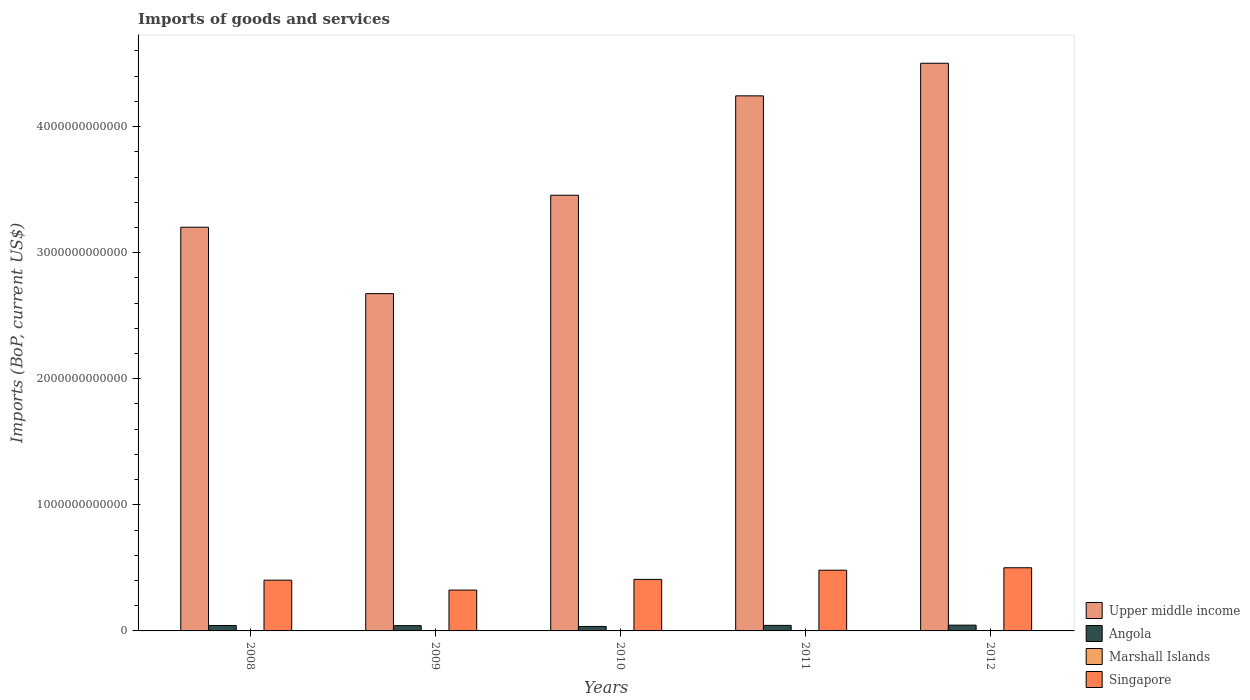How many different coloured bars are there?
Offer a terse response. 4. How many bars are there on the 5th tick from the left?
Provide a succinct answer. 4. What is the amount spent on imports in Angola in 2011?
Your answer should be compact. 4.39e+1. Across all years, what is the maximum amount spent on imports in Marshall Islands?
Your response must be concise. 1.82e+08. Across all years, what is the minimum amount spent on imports in Upper middle income?
Your answer should be compact. 2.68e+12. What is the total amount spent on imports in Angola in the graph?
Give a very brief answer. 2.10e+11. What is the difference between the amount spent on imports in Marshall Islands in 2008 and that in 2010?
Your answer should be very brief. -2.45e+07. What is the difference between the amount spent on imports in Singapore in 2008 and the amount spent on imports in Upper middle income in 2009?
Your response must be concise. -2.27e+12. What is the average amount spent on imports in Singapore per year?
Provide a succinct answer. 4.24e+11. In the year 2010, what is the difference between the amount spent on imports in Singapore and amount spent on imports in Marshall Islands?
Keep it short and to the point. 4.08e+11. In how many years, is the amount spent on imports in Marshall Islands greater than 200000000000 US$?
Your answer should be compact. 0. What is the ratio of the amount spent on imports in Marshall Islands in 2010 to that in 2012?
Your answer should be compact. 0.9. Is the amount spent on imports in Marshall Islands in 2008 less than that in 2012?
Offer a terse response. Yes. What is the difference between the highest and the second highest amount spent on imports in Angola?
Provide a succinct answer. 1.94e+09. What is the difference between the highest and the lowest amount spent on imports in Upper middle income?
Offer a terse response. 1.83e+12. In how many years, is the amount spent on imports in Angola greater than the average amount spent on imports in Angola taken over all years?
Provide a succinct answer. 3. Is the sum of the amount spent on imports in Marshall Islands in 2008 and 2009 greater than the maximum amount spent on imports in Angola across all years?
Keep it short and to the point. No. What does the 2nd bar from the left in 2012 represents?
Provide a short and direct response. Angola. What does the 1st bar from the right in 2011 represents?
Provide a short and direct response. Singapore. How many bars are there?
Your response must be concise. 20. How many years are there in the graph?
Offer a very short reply. 5. What is the difference between two consecutive major ticks on the Y-axis?
Give a very brief answer. 1.00e+12. Are the values on the major ticks of Y-axis written in scientific E-notation?
Ensure brevity in your answer.  No. Does the graph contain any zero values?
Keep it short and to the point. No. Does the graph contain grids?
Give a very brief answer. No. Where does the legend appear in the graph?
Keep it short and to the point. Bottom right. What is the title of the graph?
Provide a succinct answer. Imports of goods and services. Does "Dominica" appear as one of the legend labels in the graph?
Give a very brief answer. No. What is the label or title of the X-axis?
Keep it short and to the point. Years. What is the label or title of the Y-axis?
Offer a very short reply. Imports (BoP, current US$). What is the Imports (BoP, current US$) in Upper middle income in 2008?
Your answer should be very brief. 3.20e+12. What is the Imports (BoP, current US$) of Angola in 2008?
Keep it short and to the point. 4.31e+1. What is the Imports (BoP, current US$) of Marshall Islands in 2008?
Ensure brevity in your answer.  1.39e+08. What is the Imports (BoP, current US$) of Singapore in 2008?
Provide a succinct answer. 4.03e+11. What is the Imports (BoP, current US$) of Upper middle income in 2009?
Your response must be concise. 2.68e+12. What is the Imports (BoP, current US$) in Angola in 2009?
Make the answer very short. 4.18e+1. What is the Imports (BoP, current US$) of Marshall Islands in 2009?
Make the answer very short. 1.58e+08. What is the Imports (BoP, current US$) of Singapore in 2009?
Make the answer very short. 3.24e+11. What is the Imports (BoP, current US$) of Upper middle income in 2010?
Ensure brevity in your answer.  3.46e+12. What is the Imports (BoP, current US$) of Angola in 2010?
Give a very brief answer. 3.54e+1. What is the Imports (BoP, current US$) of Marshall Islands in 2010?
Offer a terse response. 1.64e+08. What is the Imports (BoP, current US$) in Singapore in 2010?
Offer a very short reply. 4.09e+11. What is the Imports (BoP, current US$) of Upper middle income in 2011?
Give a very brief answer. 4.24e+12. What is the Imports (BoP, current US$) of Angola in 2011?
Your answer should be very brief. 4.39e+1. What is the Imports (BoP, current US$) in Marshall Islands in 2011?
Ensure brevity in your answer.  1.75e+08. What is the Imports (BoP, current US$) of Singapore in 2011?
Offer a terse response. 4.82e+11. What is the Imports (BoP, current US$) in Upper middle income in 2012?
Your response must be concise. 4.50e+12. What is the Imports (BoP, current US$) in Angola in 2012?
Offer a very short reply. 4.58e+1. What is the Imports (BoP, current US$) of Marshall Islands in 2012?
Your answer should be very brief. 1.82e+08. What is the Imports (BoP, current US$) in Singapore in 2012?
Your response must be concise. 5.01e+11. Across all years, what is the maximum Imports (BoP, current US$) of Upper middle income?
Provide a succinct answer. 4.50e+12. Across all years, what is the maximum Imports (BoP, current US$) in Angola?
Ensure brevity in your answer.  4.58e+1. Across all years, what is the maximum Imports (BoP, current US$) in Marshall Islands?
Ensure brevity in your answer.  1.82e+08. Across all years, what is the maximum Imports (BoP, current US$) of Singapore?
Your response must be concise. 5.01e+11. Across all years, what is the minimum Imports (BoP, current US$) of Upper middle income?
Ensure brevity in your answer.  2.68e+12. Across all years, what is the minimum Imports (BoP, current US$) in Angola?
Your response must be concise. 3.54e+1. Across all years, what is the minimum Imports (BoP, current US$) in Marshall Islands?
Offer a very short reply. 1.39e+08. Across all years, what is the minimum Imports (BoP, current US$) in Singapore?
Ensure brevity in your answer.  3.24e+11. What is the total Imports (BoP, current US$) in Upper middle income in the graph?
Provide a short and direct response. 1.81e+13. What is the total Imports (BoP, current US$) in Angola in the graph?
Offer a terse response. 2.10e+11. What is the total Imports (BoP, current US$) of Marshall Islands in the graph?
Your response must be concise. 8.18e+08. What is the total Imports (BoP, current US$) of Singapore in the graph?
Offer a very short reply. 2.12e+12. What is the difference between the Imports (BoP, current US$) in Upper middle income in 2008 and that in 2009?
Ensure brevity in your answer.  5.27e+11. What is the difference between the Imports (BoP, current US$) of Angola in 2008 and that in 2009?
Ensure brevity in your answer.  1.29e+09. What is the difference between the Imports (BoP, current US$) of Marshall Islands in 2008 and that in 2009?
Provide a short and direct response. -1.88e+07. What is the difference between the Imports (BoP, current US$) of Singapore in 2008 and that in 2009?
Ensure brevity in your answer.  7.86e+1. What is the difference between the Imports (BoP, current US$) in Upper middle income in 2008 and that in 2010?
Your response must be concise. -2.54e+11. What is the difference between the Imports (BoP, current US$) of Angola in 2008 and that in 2010?
Keep it short and to the point. 7.70e+09. What is the difference between the Imports (BoP, current US$) of Marshall Islands in 2008 and that in 2010?
Your answer should be compact. -2.45e+07. What is the difference between the Imports (BoP, current US$) in Singapore in 2008 and that in 2010?
Your answer should be compact. -6.12e+09. What is the difference between the Imports (BoP, current US$) in Upper middle income in 2008 and that in 2011?
Make the answer very short. -1.04e+12. What is the difference between the Imports (BoP, current US$) in Angola in 2008 and that in 2011?
Provide a short and direct response. -7.77e+08. What is the difference between the Imports (BoP, current US$) in Marshall Islands in 2008 and that in 2011?
Your answer should be compact. -3.58e+07. What is the difference between the Imports (BoP, current US$) of Singapore in 2008 and that in 2011?
Give a very brief answer. -7.90e+1. What is the difference between the Imports (BoP, current US$) in Upper middle income in 2008 and that in 2012?
Your response must be concise. -1.30e+12. What is the difference between the Imports (BoP, current US$) of Angola in 2008 and that in 2012?
Offer a terse response. -2.71e+09. What is the difference between the Imports (BoP, current US$) of Marshall Islands in 2008 and that in 2012?
Your response must be concise. -4.28e+07. What is the difference between the Imports (BoP, current US$) of Singapore in 2008 and that in 2012?
Ensure brevity in your answer.  -9.85e+1. What is the difference between the Imports (BoP, current US$) in Upper middle income in 2009 and that in 2010?
Offer a very short reply. -7.80e+11. What is the difference between the Imports (BoP, current US$) in Angola in 2009 and that in 2010?
Provide a short and direct response. 6.41e+09. What is the difference between the Imports (BoP, current US$) of Marshall Islands in 2009 and that in 2010?
Ensure brevity in your answer.  -5.73e+06. What is the difference between the Imports (BoP, current US$) of Singapore in 2009 and that in 2010?
Your answer should be compact. -8.47e+1. What is the difference between the Imports (BoP, current US$) of Upper middle income in 2009 and that in 2011?
Keep it short and to the point. -1.57e+12. What is the difference between the Imports (BoP, current US$) in Angola in 2009 and that in 2011?
Ensure brevity in your answer.  -2.07e+09. What is the difference between the Imports (BoP, current US$) of Marshall Islands in 2009 and that in 2011?
Your answer should be very brief. -1.70e+07. What is the difference between the Imports (BoP, current US$) of Singapore in 2009 and that in 2011?
Your answer should be very brief. -1.58e+11. What is the difference between the Imports (BoP, current US$) of Upper middle income in 2009 and that in 2012?
Give a very brief answer. -1.83e+12. What is the difference between the Imports (BoP, current US$) of Angola in 2009 and that in 2012?
Make the answer very short. -4.01e+09. What is the difference between the Imports (BoP, current US$) of Marshall Islands in 2009 and that in 2012?
Give a very brief answer. -2.41e+07. What is the difference between the Imports (BoP, current US$) of Singapore in 2009 and that in 2012?
Offer a terse response. -1.77e+11. What is the difference between the Imports (BoP, current US$) in Upper middle income in 2010 and that in 2011?
Your response must be concise. -7.88e+11. What is the difference between the Imports (BoP, current US$) of Angola in 2010 and that in 2011?
Give a very brief answer. -8.48e+09. What is the difference between the Imports (BoP, current US$) of Marshall Islands in 2010 and that in 2011?
Offer a very short reply. -1.13e+07. What is the difference between the Imports (BoP, current US$) of Singapore in 2010 and that in 2011?
Offer a terse response. -7.29e+1. What is the difference between the Imports (BoP, current US$) of Upper middle income in 2010 and that in 2012?
Your answer should be compact. -1.05e+12. What is the difference between the Imports (BoP, current US$) in Angola in 2010 and that in 2012?
Your answer should be compact. -1.04e+1. What is the difference between the Imports (BoP, current US$) of Marshall Islands in 2010 and that in 2012?
Keep it short and to the point. -1.83e+07. What is the difference between the Imports (BoP, current US$) of Singapore in 2010 and that in 2012?
Offer a terse response. -9.24e+1. What is the difference between the Imports (BoP, current US$) of Upper middle income in 2011 and that in 2012?
Give a very brief answer. -2.58e+11. What is the difference between the Imports (BoP, current US$) of Angola in 2011 and that in 2012?
Provide a short and direct response. -1.94e+09. What is the difference between the Imports (BoP, current US$) in Marshall Islands in 2011 and that in 2012?
Your answer should be compact. -7.07e+06. What is the difference between the Imports (BoP, current US$) in Singapore in 2011 and that in 2012?
Give a very brief answer. -1.94e+1. What is the difference between the Imports (BoP, current US$) in Upper middle income in 2008 and the Imports (BoP, current US$) in Angola in 2009?
Your answer should be very brief. 3.16e+12. What is the difference between the Imports (BoP, current US$) in Upper middle income in 2008 and the Imports (BoP, current US$) in Marshall Islands in 2009?
Your answer should be very brief. 3.20e+12. What is the difference between the Imports (BoP, current US$) of Upper middle income in 2008 and the Imports (BoP, current US$) of Singapore in 2009?
Ensure brevity in your answer.  2.88e+12. What is the difference between the Imports (BoP, current US$) of Angola in 2008 and the Imports (BoP, current US$) of Marshall Islands in 2009?
Keep it short and to the point. 4.30e+1. What is the difference between the Imports (BoP, current US$) in Angola in 2008 and the Imports (BoP, current US$) in Singapore in 2009?
Offer a very short reply. -2.81e+11. What is the difference between the Imports (BoP, current US$) of Marshall Islands in 2008 and the Imports (BoP, current US$) of Singapore in 2009?
Offer a terse response. -3.24e+11. What is the difference between the Imports (BoP, current US$) in Upper middle income in 2008 and the Imports (BoP, current US$) in Angola in 2010?
Make the answer very short. 3.17e+12. What is the difference between the Imports (BoP, current US$) of Upper middle income in 2008 and the Imports (BoP, current US$) of Marshall Islands in 2010?
Provide a succinct answer. 3.20e+12. What is the difference between the Imports (BoP, current US$) in Upper middle income in 2008 and the Imports (BoP, current US$) in Singapore in 2010?
Offer a very short reply. 2.79e+12. What is the difference between the Imports (BoP, current US$) in Angola in 2008 and the Imports (BoP, current US$) in Marshall Islands in 2010?
Your answer should be compact. 4.30e+1. What is the difference between the Imports (BoP, current US$) in Angola in 2008 and the Imports (BoP, current US$) in Singapore in 2010?
Offer a very short reply. -3.66e+11. What is the difference between the Imports (BoP, current US$) of Marshall Islands in 2008 and the Imports (BoP, current US$) of Singapore in 2010?
Your answer should be very brief. -4.08e+11. What is the difference between the Imports (BoP, current US$) in Upper middle income in 2008 and the Imports (BoP, current US$) in Angola in 2011?
Your answer should be very brief. 3.16e+12. What is the difference between the Imports (BoP, current US$) in Upper middle income in 2008 and the Imports (BoP, current US$) in Marshall Islands in 2011?
Your answer should be very brief. 3.20e+12. What is the difference between the Imports (BoP, current US$) of Upper middle income in 2008 and the Imports (BoP, current US$) of Singapore in 2011?
Keep it short and to the point. 2.72e+12. What is the difference between the Imports (BoP, current US$) in Angola in 2008 and the Imports (BoP, current US$) in Marshall Islands in 2011?
Make the answer very short. 4.29e+1. What is the difference between the Imports (BoP, current US$) in Angola in 2008 and the Imports (BoP, current US$) in Singapore in 2011?
Offer a very short reply. -4.38e+11. What is the difference between the Imports (BoP, current US$) of Marshall Islands in 2008 and the Imports (BoP, current US$) of Singapore in 2011?
Your answer should be compact. -4.81e+11. What is the difference between the Imports (BoP, current US$) of Upper middle income in 2008 and the Imports (BoP, current US$) of Angola in 2012?
Provide a succinct answer. 3.16e+12. What is the difference between the Imports (BoP, current US$) of Upper middle income in 2008 and the Imports (BoP, current US$) of Marshall Islands in 2012?
Give a very brief answer. 3.20e+12. What is the difference between the Imports (BoP, current US$) of Upper middle income in 2008 and the Imports (BoP, current US$) of Singapore in 2012?
Ensure brevity in your answer.  2.70e+12. What is the difference between the Imports (BoP, current US$) of Angola in 2008 and the Imports (BoP, current US$) of Marshall Islands in 2012?
Your response must be concise. 4.29e+1. What is the difference between the Imports (BoP, current US$) of Angola in 2008 and the Imports (BoP, current US$) of Singapore in 2012?
Your answer should be compact. -4.58e+11. What is the difference between the Imports (BoP, current US$) of Marshall Islands in 2008 and the Imports (BoP, current US$) of Singapore in 2012?
Your answer should be very brief. -5.01e+11. What is the difference between the Imports (BoP, current US$) in Upper middle income in 2009 and the Imports (BoP, current US$) in Angola in 2010?
Provide a short and direct response. 2.64e+12. What is the difference between the Imports (BoP, current US$) of Upper middle income in 2009 and the Imports (BoP, current US$) of Marshall Islands in 2010?
Provide a succinct answer. 2.68e+12. What is the difference between the Imports (BoP, current US$) of Upper middle income in 2009 and the Imports (BoP, current US$) of Singapore in 2010?
Offer a terse response. 2.27e+12. What is the difference between the Imports (BoP, current US$) in Angola in 2009 and the Imports (BoP, current US$) in Marshall Islands in 2010?
Offer a terse response. 4.17e+1. What is the difference between the Imports (BoP, current US$) of Angola in 2009 and the Imports (BoP, current US$) of Singapore in 2010?
Your answer should be very brief. -3.67e+11. What is the difference between the Imports (BoP, current US$) in Marshall Islands in 2009 and the Imports (BoP, current US$) in Singapore in 2010?
Your answer should be compact. -4.08e+11. What is the difference between the Imports (BoP, current US$) in Upper middle income in 2009 and the Imports (BoP, current US$) in Angola in 2011?
Provide a short and direct response. 2.63e+12. What is the difference between the Imports (BoP, current US$) in Upper middle income in 2009 and the Imports (BoP, current US$) in Marshall Islands in 2011?
Make the answer very short. 2.68e+12. What is the difference between the Imports (BoP, current US$) in Upper middle income in 2009 and the Imports (BoP, current US$) in Singapore in 2011?
Provide a succinct answer. 2.19e+12. What is the difference between the Imports (BoP, current US$) of Angola in 2009 and the Imports (BoP, current US$) of Marshall Islands in 2011?
Provide a short and direct response. 4.17e+1. What is the difference between the Imports (BoP, current US$) of Angola in 2009 and the Imports (BoP, current US$) of Singapore in 2011?
Ensure brevity in your answer.  -4.40e+11. What is the difference between the Imports (BoP, current US$) in Marshall Islands in 2009 and the Imports (BoP, current US$) in Singapore in 2011?
Your response must be concise. -4.81e+11. What is the difference between the Imports (BoP, current US$) in Upper middle income in 2009 and the Imports (BoP, current US$) in Angola in 2012?
Provide a short and direct response. 2.63e+12. What is the difference between the Imports (BoP, current US$) in Upper middle income in 2009 and the Imports (BoP, current US$) in Marshall Islands in 2012?
Ensure brevity in your answer.  2.68e+12. What is the difference between the Imports (BoP, current US$) of Upper middle income in 2009 and the Imports (BoP, current US$) of Singapore in 2012?
Give a very brief answer. 2.17e+12. What is the difference between the Imports (BoP, current US$) in Angola in 2009 and the Imports (BoP, current US$) in Marshall Islands in 2012?
Your answer should be very brief. 4.16e+1. What is the difference between the Imports (BoP, current US$) in Angola in 2009 and the Imports (BoP, current US$) in Singapore in 2012?
Your response must be concise. -4.59e+11. What is the difference between the Imports (BoP, current US$) in Marshall Islands in 2009 and the Imports (BoP, current US$) in Singapore in 2012?
Give a very brief answer. -5.01e+11. What is the difference between the Imports (BoP, current US$) in Upper middle income in 2010 and the Imports (BoP, current US$) in Angola in 2011?
Provide a short and direct response. 3.41e+12. What is the difference between the Imports (BoP, current US$) of Upper middle income in 2010 and the Imports (BoP, current US$) of Marshall Islands in 2011?
Provide a short and direct response. 3.46e+12. What is the difference between the Imports (BoP, current US$) in Upper middle income in 2010 and the Imports (BoP, current US$) in Singapore in 2011?
Your answer should be compact. 2.97e+12. What is the difference between the Imports (BoP, current US$) in Angola in 2010 and the Imports (BoP, current US$) in Marshall Islands in 2011?
Your answer should be compact. 3.52e+1. What is the difference between the Imports (BoP, current US$) in Angola in 2010 and the Imports (BoP, current US$) in Singapore in 2011?
Offer a very short reply. -4.46e+11. What is the difference between the Imports (BoP, current US$) of Marshall Islands in 2010 and the Imports (BoP, current US$) of Singapore in 2011?
Offer a terse response. -4.81e+11. What is the difference between the Imports (BoP, current US$) of Upper middle income in 2010 and the Imports (BoP, current US$) of Angola in 2012?
Provide a succinct answer. 3.41e+12. What is the difference between the Imports (BoP, current US$) of Upper middle income in 2010 and the Imports (BoP, current US$) of Marshall Islands in 2012?
Give a very brief answer. 3.46e+12. What is the difference between the Imports (BoP, current US$) in Upper middle income in 2010 and the Imports (BoP, current US$) in Singapore in 2012?
Offer a very short reply. 2.95e+12. What is the difference between the Imports (BoP, current US$) in Angola in 2010 and the Imports (BoP, current US$) in Marshall Islands in 2012?
Your answer should be compact. 3.52e+1. What is the difference between the Imports (BoP, current US$) in Angola in 2010 and the Imports (BoP, current US$) in Singapore in 2012?
Make the answer very short. -4.66e+11. What is the difference between the Imports (BoP, current US$) in Marshall Islands in 2010 and the Imports (BoP, current US$) in Singapore in 2012?
Provide a succinct answer. -5.01e+11. What is the difference between the Imports (BoP, current US$) in Upper middle income in 2011 and the Imports (BoP, current US$) in Angola in 2012?
Ensure brevity in your answer.  4.20e+12. What is the difference between the Imports (BoP, current US$) of Upper middle income in 2011 and the Imports (BoP, current US$) of Marshall Islands in 2012?
Your answer should be compact. 4.24e+12. What is the difference between the Imports (BoP, current US$) in Upper middle income in 2011 and the Imports (BoP, current US$) in Singapore in 2012?
Your answer should be compact. 3.74e+12. What is the difference between the Imports (BoP, current US$) in Angola in 2011 and the Imports (BoP, current US$) in Marshall Islands in 2012?
Your answer should be compact. 4.37e+1. What is the difference between the Imports (BoP, current US$) of Angola in 2011 and the Imports (BoP, current US$) of Singapore in 2012?
Ensure brevity in your answer.  -4.57e+11. What is the difference between the Imports (BoP, current US$) of Marshall Islands in 2011 and the Imports (BoP, current US$) of Singapore in 2012?
Give a very brief answer. -5.01e+11. What is the average Imports (BoP, current US$) in Upper middle income per year?
Your response must be concise. 3.62e+12. What is the average Imports (BoP, current US$) in Angola per year?
Provide a succinct answer. 4.20e+1. What is the average Imports (BoP, current US$) of Marshall Islands per year?
Your response must be concise. 1.64e+08. What is the average Imports (BoP, current US$) of Singapore per year?
Provide a succinct answer. 4.24e+11. In the year 2008, what is the difference between the Imports (BoP, current US$) in Upper middle income and Imports (BoP, current US$) in Angola?
Give a very brief answer. 3.16e+12. In the year 2008, what is the difference between the Imports (BoP, current US$) of Upper middle income and Imports (BoP, current US$) of Marshall Islands?
Make the answer very short. 3.20e+12. In the year 2008, what is the difference between the Imports (BoP, current US$) of Upper middle income and Imports (BoP, current US$) of Singapore?
Ensure brevity in your answer.  2.80e+12. In the year 2008, what is the difference between the Imports (BoP, current US$) of Angola and Imports (BoP, current US$) of Marshall Islands?
Offer a very short reply. 4.30e+1. In the year 2008, what is the difference between the Imports (BoP, current US$) of Angola and Imports (BoP, current US$) of Singapore?
Provide a short and direct response. -3.59e+11. In the year 2008, what is the difference between the Imports (BoP, current US$) of Marshall Islands and Imports (BoP, current US$) of Singapore?
Keep it short and to the point. -4.02e+11. In the year 2009, what is the difference between the Imports (BoP, current US$) of Upper middle income and Imports (BoP, current US$) of Angola?
Ensure brevity in your answer.  2.63e+12. In the year 2009, what is the difference between the Imports (BoP, current US$) of Upper middle income and Imports (BoP, current US$) of Marshall Islands?
Offer a very short reply. 2.68e+12. In the year 2009, what is the difference between the Imports (BoP, current US$) of Upper middle income and Imports (BoP, current US$) of Singapore?
Ensure brevity in your answer.  2.35e+12. In the year 2009, what is the difference between the Imports (BoP, current US$) in Angola and Imports (BoP, current US$) in Marshall Islands?
Offer a very short reply. 4.17e+1. In the year 2009, what is the difference between the Imports (BoP, current US$) of Angola and Imports (BoP, current US$) of Singapore?
Keep it short and to the point. -2.82e+11. In the year 2009, what is the difference between the Imports (BoP, current US$) of Marshall Islands and Imports (BoP, current US$) of Singapore?
Make the answer very short. -3.24e+11. In the year 2010, what is the difference between the Imports (BoP, current US$) in Upper middle income and Imports (BoP, current US$) in Angola?
Keep it short and to the point. 3.42e+12. In the year 2010, what is the difference between the Imports (BoP, current US$) of Upper middle income and Imports (BoP, current US$) of Marshall Islands?
Provide a succinct answer. 3.46e+12. In the year 2010, what is the difference between the Imports (BoP, current US$) of Upper middle income and Imports (BoP, current US$) of Singapore?
Keep it short and to the point. 3.05e+12. In the year 2010, what is the difference between the Imports (BoP, current US$) in Angola and Imports (BoP, current US$) in Marshall Islands?
Offer a very short reply. 3.53e+1. In the year 2010, what is the difference between the Imports (BoP, current US$) in Angola and Imports (BoP, current US$) in Singapore?
Provide a short and direct response. -3.73e+11. In the year 2010, what is the difference between the Imports (BoP, current US$) in Marshall Islands and Imports (BoP, current US$) in Singapore?
Your response must be concise. -4.08e+11. In the year 2011, what is the difference between the Imports (BoP, current US$) of Upper middle income and Imports (BoP, current US$) of Angola?
Your answer should be compact. 4.20e+12. In the year 2011, what is the difference between the Imports (BoP, current US$) in Upper middle income and Imports (BoP, current US$) in Marshall Islands?
Your answer should be compact. 4.24e+12. In the year 2011, what is the difference between the Imports (BoP, current US$) in Upper middle income and Imports (BoP, current US$) in Singapore?
Provide a succinct answer. 3.76e+12. In the year 2011, what is the difference between the Imports (BoP, current US$) in Angola and Imports (BoP, current US$) in Marshall Islands?
Make the answer very short. 4.37e+1. In the year 2011, what is the difference between the Imports (BoP, current US$) of Angola and Imports (BoP, current US$) of Singapore?
Offer a terse response. -4.38e+11. In the year 2011, what is the difference between the Imports (BoP, current US$) in Marshall Islands and Imports (BoP, current US$) in Singapore?
Ensure brevity in your answer.  -4.81e+11. In the year 2012, what is the difference between the Imports (BoP, current US$) in Upper middle income and Imports (BoP, current US$) in Angola?
Ensure brevity in your answer.  4.46e+12. In the year 2012, what is the difference between the Imports (BoP, current US$) in Upper middle income and Imports (BoP, current US$) in Marshall Islands?
Ensure brevity in your answer.  4.50e+12. In the year 2012, what is the difference between the Imports (BoP, current US$) in Upper middle income and Imports (BoP, current US$) in Singapore?
Offer a terse response. 4.00e+12. In the year 2012, what is the difference between the Imports (BoP, current US$) in Angola and Imports (BoP, current US$) in Marshall Islands?
Offer a very short reply. 4.57e+1. In the year 2012, what is the difference between the Imports (BoP, current US$) of Angola and Imports (BoP, current US$) of Singapore?
Provide a succinct answer. -4.55e+11. In the year 2012, what is the difference between the Imports (BoP, current US$) in Marshall Islands and Imports (BoP, current US$) in Singapore?
Offer a very short reply. -5.01e+11. What is the ratio of the Imports (BoP, current US$) in Upper middle income in 2008 to that in 2009?
Your answer should be compact. 1.2. What is the ratio of the Imports (BoP, current US$) in Angola in 2008 to that in 2009?
Keep it short and to the point. 1.03. What is the ratio of the Imports (BoP, current US$) in Marshall Islands in 2008 to that in 2009?
Offer a very short reply. 0.88. What is the ratio of the Imports (BoP, current US$) in Singapore in 2008 to that in 2009?
Ensure brevity in your answer.  1.24. What is the ratio of the Imports (BoP, current US$) in Upper middle income in 2008 to that in 2010?
Offer a terse response. 0.93. What is the ratio of the Imports (BoP, current US$) in Angola in 2008 to that in 2010?
Provide a short and direct response. 1.22. What is the ratio of the Imports (BoP, current US$) in Marshall Islands in 2008 to that in 2010?
Give a very brief answer. 0.85. What is the ratio of the Imports (BoP, current US$) of Upper middle income in 2008 to that in 2011?
Make the answer very short. 0.75. What is the ratio of the Imports (BoP, current US$) of Angola in 2008 to that in 2011?
Make the answer very short. 0.98. What is the ratio of the Imports (BoP, current US$) in Marshall Islands in 2008 to that in 2011?
Your answer should be very brief. 0.8. What is the ratio of the Imports (BoP, current US$) in Singapore in 2008 to that in 2011?
Offer a terse response. 0.84. What is the ratio of the Imports (BoP, current US$) in Upper middle income in 2008 to that in 2012?
Ensure brevity in your answer.  0.71. What is the ratio of the Imports (BoP, current US$) in Angola in 2008 to that in 2012?
Provide a succinct answer. 0.94. What is the ratio of the Imports (BoP, current US$) in Marshall Islands in 2008 to that in 2012?
Your answer should be compact. 0.76. What is the ratio of the Imports (BoP, current US$) of Singapore in 2008 to that in 2012?
Provide a short and direct response. 0.8. What is the ratio of the Imports (BoP, current US$) in Upper middle income in 2009 to that in 2010?
Ensure brevity in your answer.  0.77. What is the ratio of the Imports (BoP, current US$) of Angola in 2009 to that in 2010?
Offer a terse response. 1.18. What is the ratio of the Imports (BoP, current US$) in Marshall Islands in 2009 to that in 2010?
Make the answer very short. 0.96. What is the ratio of the Imports (BoP, current US$) in Singapore in 2009 to that in 2010?
Provide a succinct answer. 0.79. What is the ratio of the Imports (BoP, current US$) in Upper middle income in 2009 to that in 2011?
Your answer should be compact. 0.63. What is the ratio of the Imports (BoP, current US$) in Angola in 2009 to that in 2011?
Your response must be concise. 0.95. What is the ratio of the Imports (BoP, current US$) in Marshall Islands in 2009 to that in 2011?
Your response must be concise. 0.9. What is the ratio of the Imports (BoP, current US$) of Singapore in 2009 to that in 2011?
Offer a terse response. 0.67. What is the ratio of the Imports (BoP, current US$) of Upper middle income in 2009 to that in 2012?
Your answer should be compact. 0.59. What is the ratio of the Imports (BoP, current US$) in Angola in 2009 to that in 2012?
Offer a terse response. 0.91. What is the ratio of the Imports (BoP, current US$) of Marshall Islands in 2009 to that in 2012?
Your response must be concise. 0.87. What is the ratio of the Imports (BoP, current US$) in Singapore in 2009 to that in 2012?
Your answer should be compact. 0.65. What is the ratio of the Imports (BoP, current US$) of Upper middle income in 2010 to that in 2011?
Keep it short and to the point. 0.81. What is the ratio of the Imports (BoP, current US$) in Angola in 2010 to that in 2011?
Your answer should be compact. 0.81. What is the ratio of the Imports (BoP, current US$) of Marshall Islands in 2010 to that in 2011?
Ensure brevity in your answer.  0.94. What is the ratio of the Imports (BoP, current US$) in Singapore in 2010 to that in 2011?
Ensure brevity in your answer.  0.85. What is the ratio of the Imports (BoP, current US$) in Upper middle income in 2010 to that in 2012?
Your response must be concise. 0.77. What is the ratio of the Imports (BoP, current US$) of Angola in 2010 to that in 2012?
Keep it short and to the point. 0.77. What is the ratio of the Imports (BoP, current US$) of Marshall Islands in 2010 to that in 2012?
Offer a very short reply. 0.9. What is the ratio of the Imports (BoP, current US$) in Singapore in 2010 to that in 2012?
Offer a terse response. 0.82. What is the ratio of the Imports (BoP, current US$) of Upper middle income in 2011 to that in 2012?
Offer a very short reply. 0.94. What is the ratio of the Imports (BoP, current US$) in Angola in 2011 to that in 2012?
Provide a short and direct response. 0.96. What is the ratio of the Imports (BoP, current US$) of Marshall Islands in 2011 to that in 2012?
Make the answer very short. 0.96. What is the ratio of the Imports (BoP, current US$) of Singapore in 2011 to that in 2012?
Your response must be concise. 0.96. What is the difference between the highest and the second highest Imports (BoP, current US$) of Upper middle income?
Offer a very short reply. 2.58e+11. What is the difference between the highest and the second highest Imports (BoP, current US$) of Angola?
Provide a short and direct response. 1.94e+09. What is the difference between the highest and the second highest Imports (BoP, current US$) of Marshall Islands?
Give a very brief answer. 7.07e+06. What is the difference between the highest and the second highest Imports (BoP, current US$) in Singapore?
Ensure brevity in your answer.  1.94e+1. What is the difference between the highest and the lowest Imports (BoP, current US$) of Upper middle income?
Ensure brevity in your answer.  1.83e+12. What is the difference between the highest and the lowest Imports (BoP, current US$) in Angola?
Give a very brief answer. 1.04e+1. What is the difference between the highest and the lowest Imports (BoP, current US$) in Marshall Islands?
Provide a succinct answer. 4.28e+07. What is the difference between the highest and the lowest Imports (BoP, current US$) of Singapore?
Your response must be concise. 1.77e+11. 